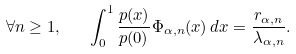<formula> <loc_0><loc_0><loc_500><loc_500>\forall n \geq 1 , \quad \int _ { 0 } ^ { 1 } \frac { p ( x ) } { p ( 0 ) } \Phi _ { \alpha , n } ( x ) \, d x = \frac { r _ { \alpha , n } } { \lambda _ { \alpha , n } } .</formula> 